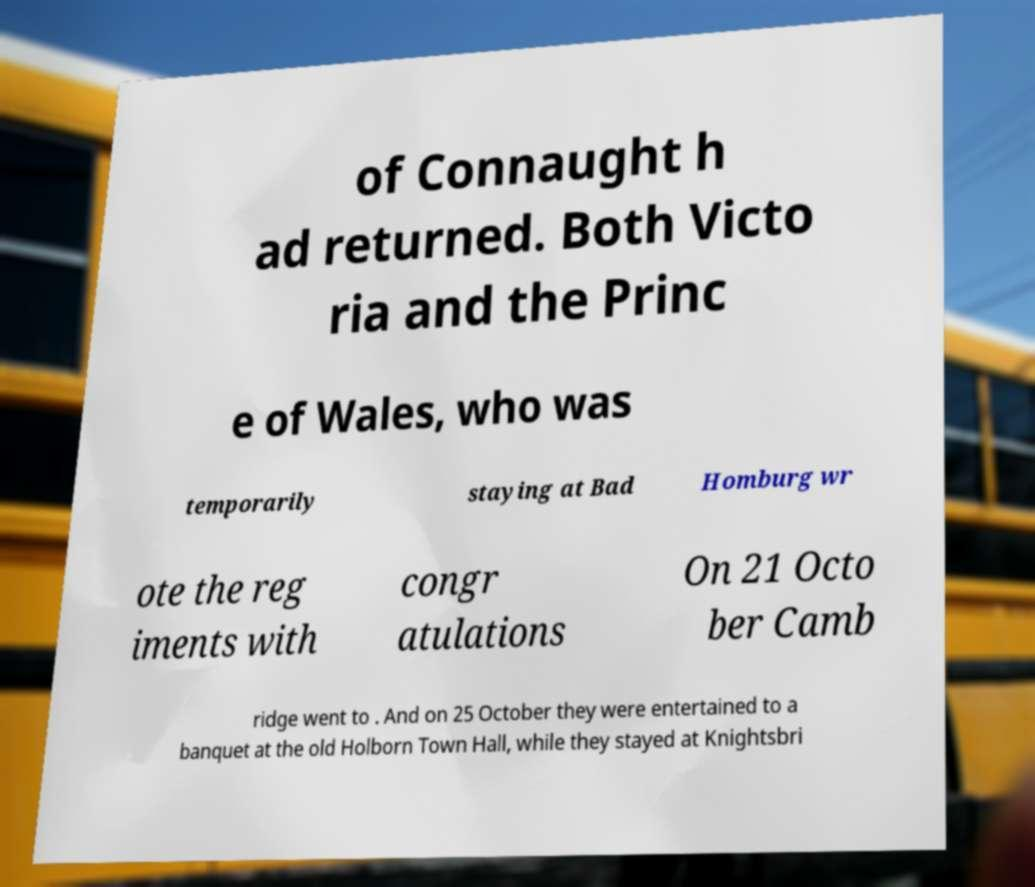Could you assist in decoding the text presented in this image and type it out clearly? of Connaught h ad returned. Both Victo ria and the Princ e of Wales, who was temporarily staying at Bad Homburg wr ote the reg iments with congr atulations On 21 Octo ber Camb ridge went to . And on 25 October they were entertained to a banquet at the old Holborn Town Hall, while they stayed at Knightsbri 